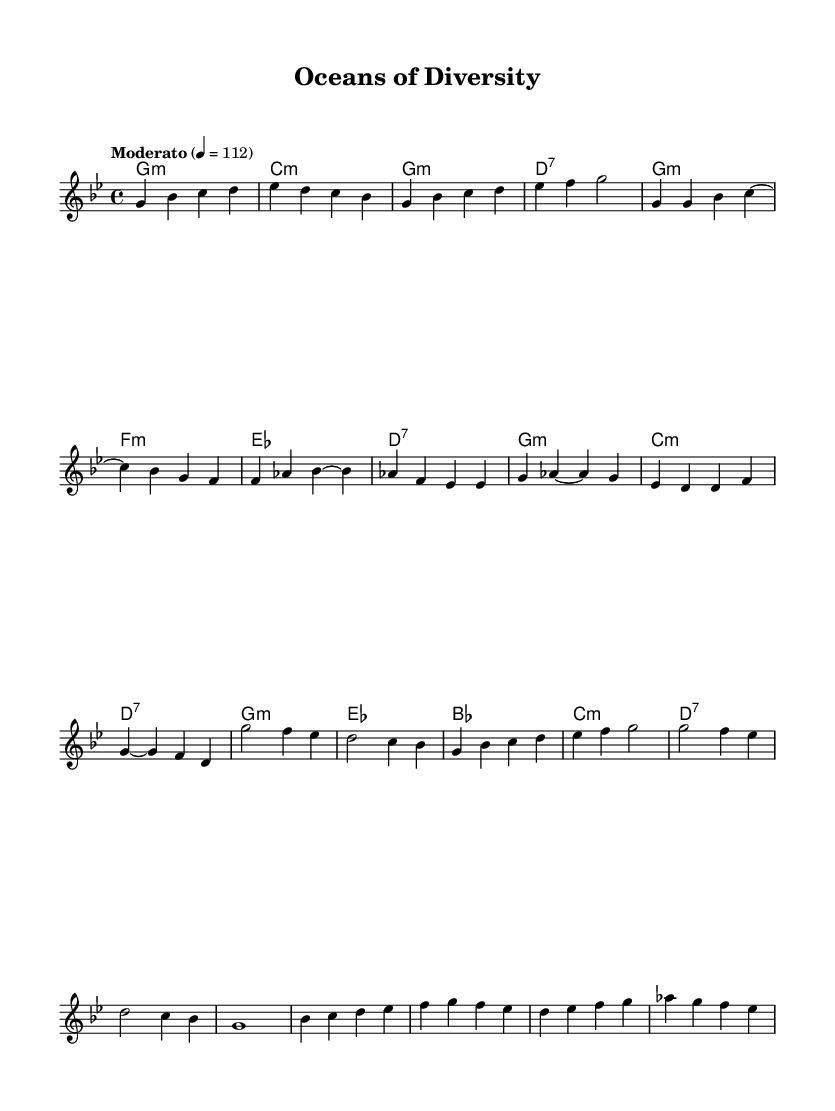What is the key signature of this music? The key signature is G minor, which has two flats: B flat and E flat.
Answer: G minor What is the time signature of this music? The time signature is 4/4, which means there are four beats in each measure.
Answer: 4/4 What is the tempo marking for this piece? The tempo marking is "Moderato," indicating a moderate pace, set at a quarter note value of 112 beats per minute.
Answer: Moderato Which section is likely to emphasize vocal performance? The Chorus section is typically where the melody is most expressive and lyrical, often highlighting vocal performance in blues and samba genres.
Answer: Chorus How many measures are in the bridge section? The bridge section consists of four measures, as indicated by the layout of the music notation in that section.
Answer: 4 What type of chord progression is predominantly used in the verse? The chord progression in the verse is characterized by minor chords, specifically using G minor, F minor, E flat major, and D7.
Answer: Minor chords What genre fusion does this sheet music represent? The music is a fusion of blues and samba, which incorporates elements of both styles to celebrate diversity.
Answer: Blues-samba fusion 